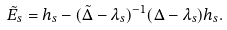<formula> <loc_0><loc_0><loc_500><loc_500>\tilde { E } _ { s } = h _ { s } - ( \tilde { \Delta } - \lambda _ { s } ) ^ { - 1 } ( \Delta - \lambda _ { s } ) h _ { s } .</formula> 